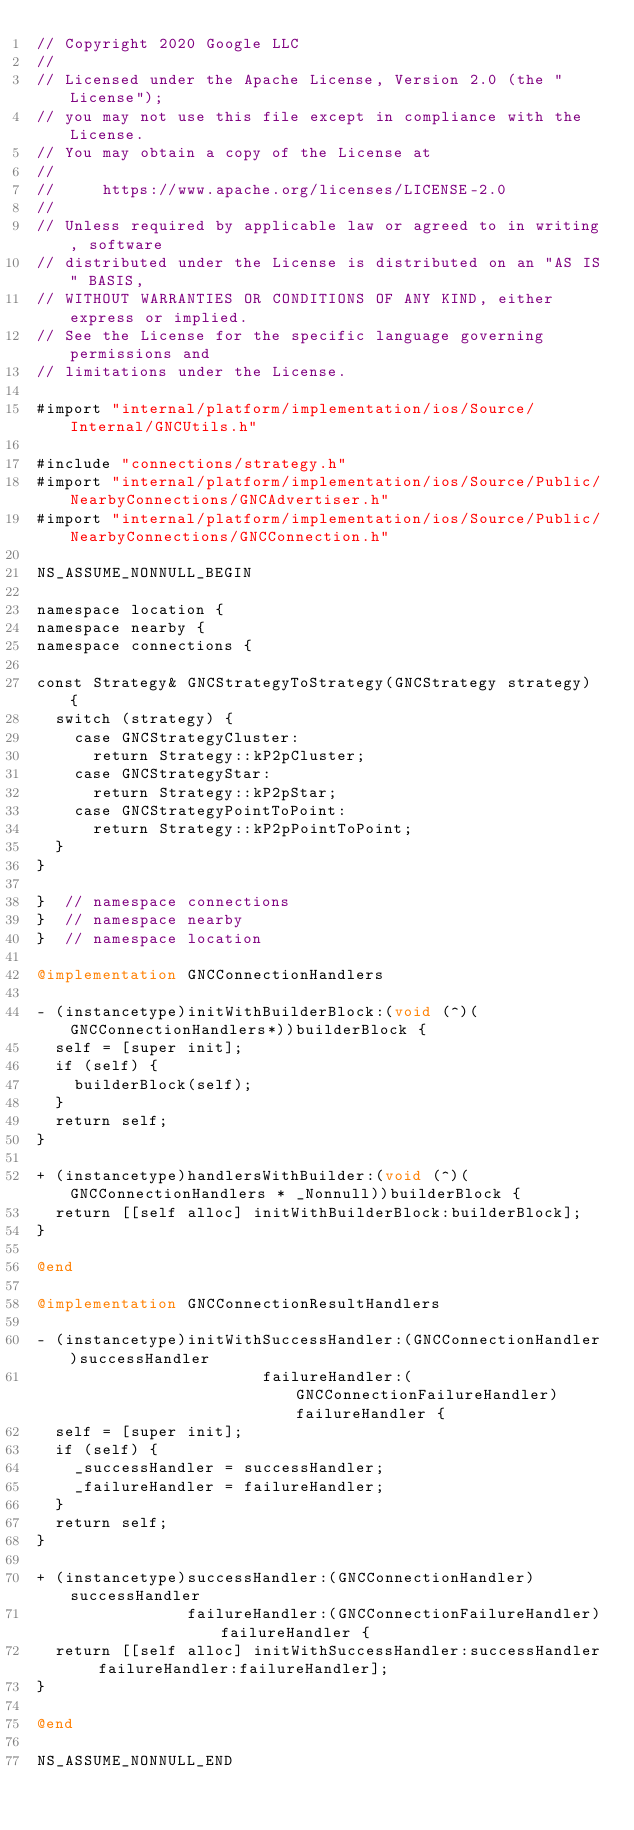Convert code to text. <code><loc_0><loc_0><loc_500><loc_500><_ObjectiveC_>// Copyright 2020 Google LLC
//
// Licensed under the Apache License, Version 2.0 (the "License");
// you may not use this file except in compliance with the License.
// You may obtain a copy of the License at
//
//     https://www.apache.org/licenses/LICENSE-2.0
//
// Unless required by applicable law or agreed to in writing, software
// distributed under the License is distributed on an "AS IS" BASIS,
// WITHOUT WARRANTIES OR CONDITIONS OF ANY KIND, either express or implied.
// See the License for the specific language governing permissions and
// limitations under the License.

#import "internal/platform/implementation/ios/Source/Internal/GNCUtils.h"

#include "connections/strategy.h"
#import "internal/platform/implementation/ios/Source/Public/NearbyConnections/GNCAdvertiser.h"
#import "internal/platform/implementation/ios/Source/Public/NearbyConnections/GNCConnection.h"

NS_ASSUME_NONNULL_BEGIN

namespace location {
namespace nearby {
namespace connections {

const Strategy& GNCStrategyToStrategy(GNCStrategy strategy) {
  switch (strategy) {
    case GNCStrategyCluster:
      return Strategy::kP2pCluster;
    case GNCStrategyStar:
      return Strategy::kP2pStar;
    case GNCStrategyPointToPoint:
      return Strategy::kP2pPointToPoint;
  }
}

}  // namespace connections
}  // namespace nearby
}  // namespace location

@implementation GNCConnectionHandlers

- (instancetype)initWithBuilderBlock:(void (^)(GNCConnectionHandlers*))builderBlock {
  self = [super init];
  if (self) {
    builderBlock(self);
  }
  return self;
}

+ (instancetype)handlersWithBuilder:(void (^)(GNCConnectionHandlers * _Nonnull))builderBlock {
  return [[self alloc] initWithBuilderBlock:builderBlock];
}

@end

@implementation GNCConnectionResultHandlers

- (instancetype)initWithSuccessHandler:(GNCConnectionHandler)successHandler
                        failureHandler:(GNCConnectionFailureHandler)failureHandler {
  self = [super init];
  if (self) {
    _successHandler = successHandler;
    _failureHandler = failureHandler;
  }
  return self;
}

+ (instancetype)successHandler:(GNCConnectionHandler)successHandler
                failureHandler:(GNCConnectionFailureHandler)failureHandler {
  return [[self alloc] initWithSuccessHandler:successHandler failureHandler:failureHandler];
}

@end

NS_ASSUME_NONNULL_END
</code> 